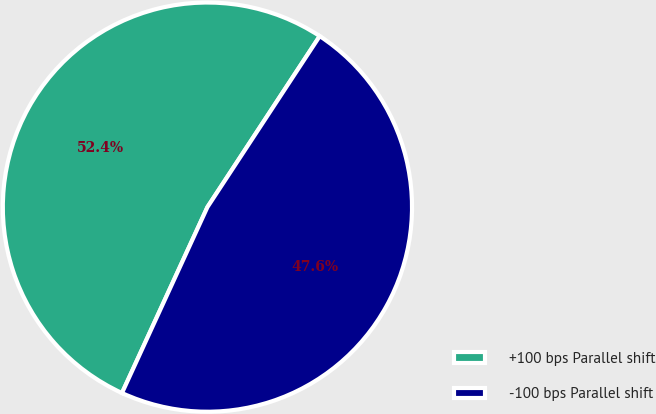<chart> <loc_0><loc_0><loc_500><loc_500><pie_chart><fcel>+100 bps Parallel shift<fcel>-100 bps Parallel shift<nl><fcel>52.39%<fcel>47.61%<nl></chart> 